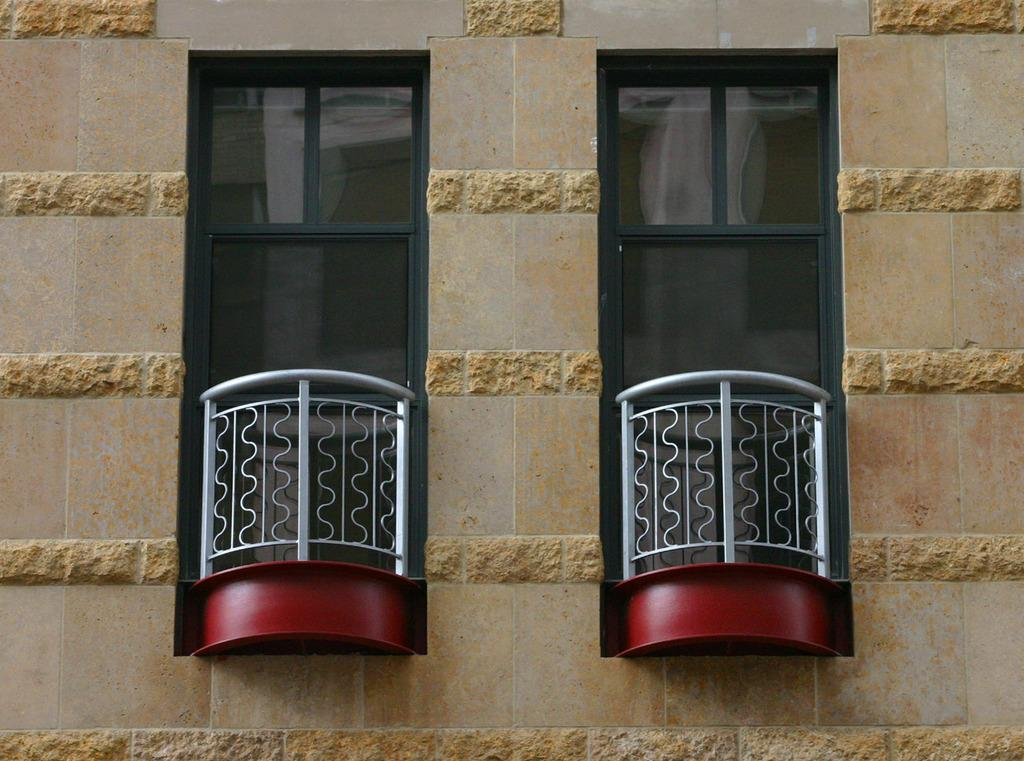What is the main subject of the image? The main subject of the image is a building wall. Are there any openings in the building wall? Yes, there are windows in the image. What time of day was the image taken? The image was taken during the day. What flavor of wind can be tasted in the image? There is no wind present in the image, and therefore no flavor can be tasted. Are there any flies visible in the image? There are no flies present in the image. 